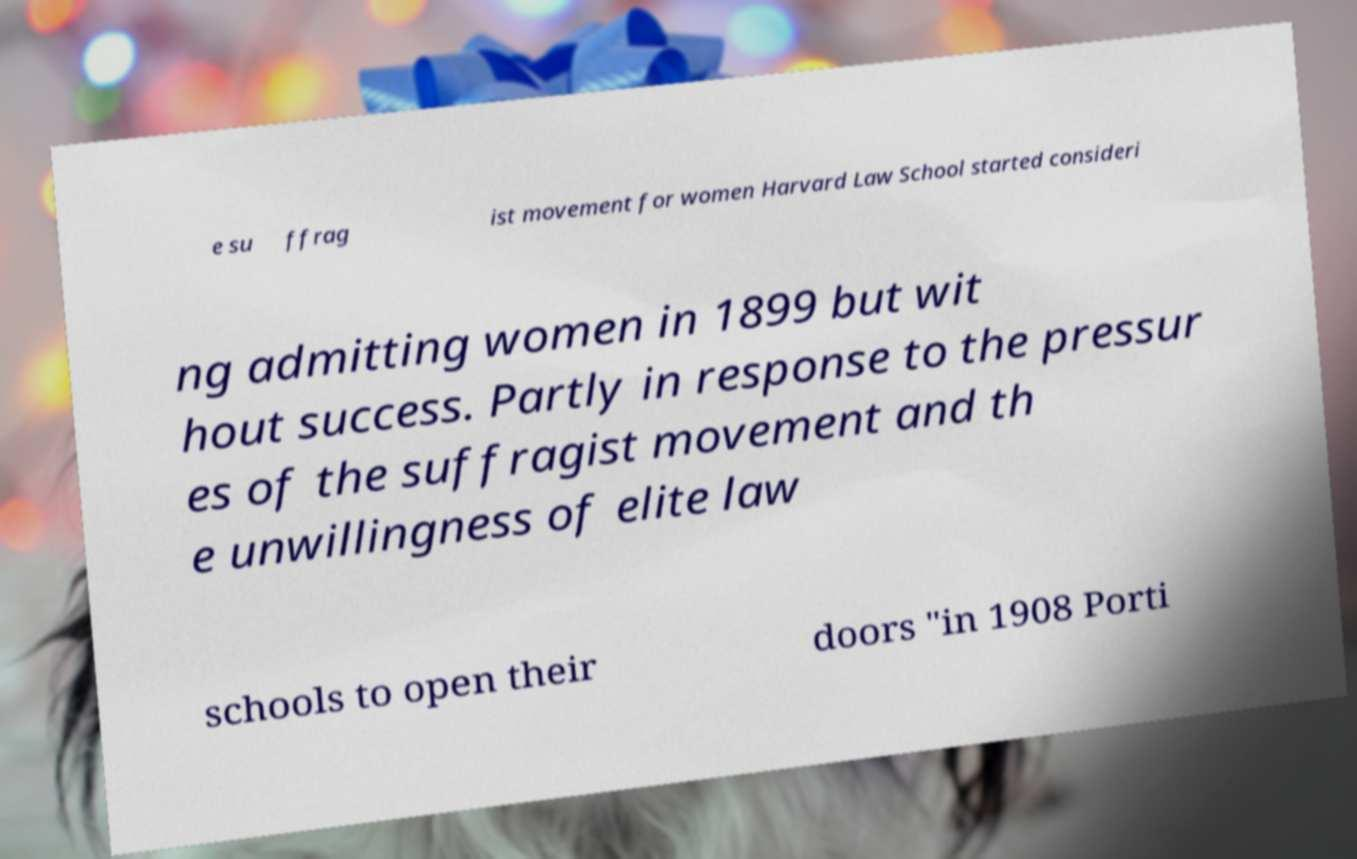Can you accurately transcribe the text from the provided image for me? e su ffrag ist movement for women Harvard Law School started consideri ng admitting women in 1899 but wit hout success. Partly in response to the pressur es of the suffragist movement and th e unwillingness of elite law schools to open their doors "in 1908 Porti 